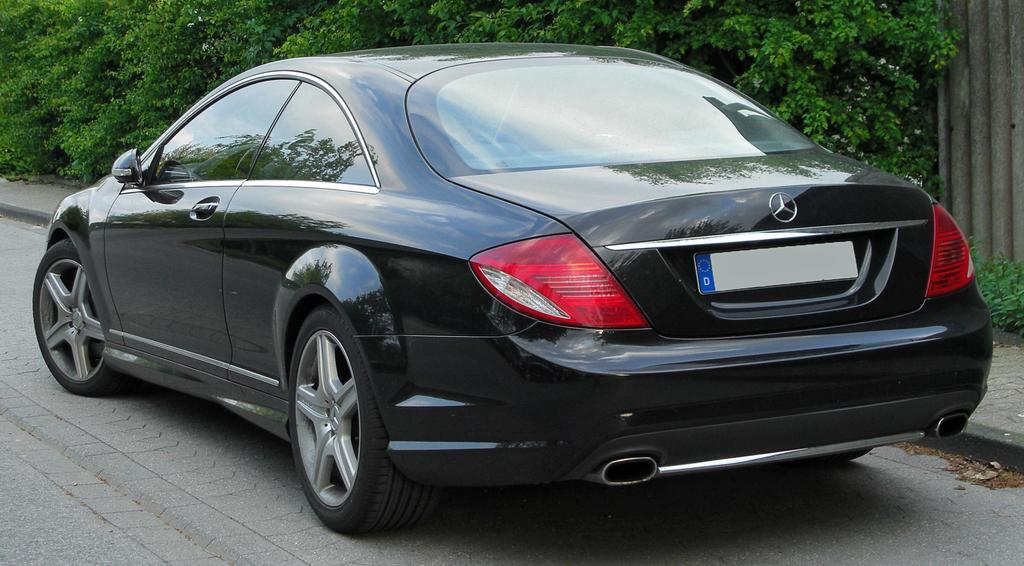What color is the car in the image? The car in the image is black. Where is the car located in the image? The car is on the side of the road. What can be seen behind the car in the image? There are plants behind the car. How many kitties are sitting on the car's hood in the image? There are no kitties present in the image; it only shows a black car on the side of the road with plants behind it. 